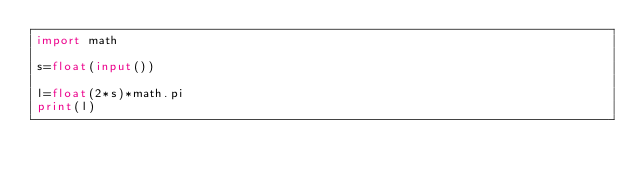Convert code to text. <code><loc_0><loc_0><loc_500><loc_500><_Python_>import math

s=float(input())

l=float(2*s)*math.pi
print(l)</code> 